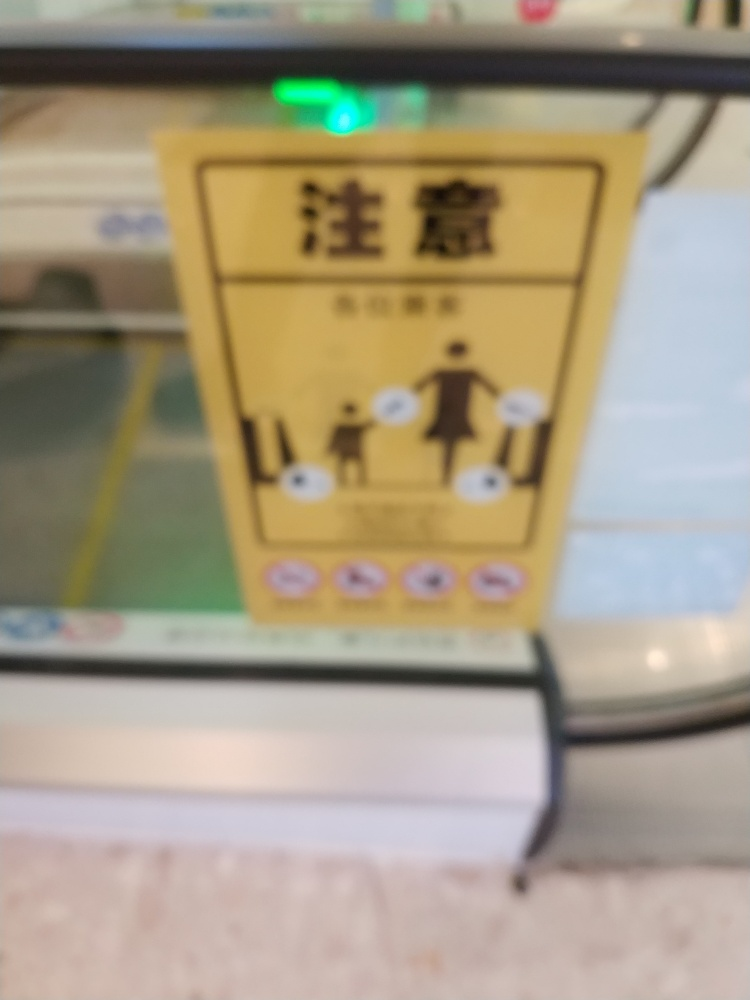Can you describe the colors that predominate in this image? The image appears to be dominated by muted colors due to the focus issue. However, there seems to be yellow as the primary color on the signage and various other colors indicating instructions or labels. Can you tell what the sign might be indicating, despite the focus issue? Even though the specific text or symbols are not clear, the sign appears to be instructional, possibly related to public transportation or facility usage, which is common for signs positioned at eye-level in public spaces. 